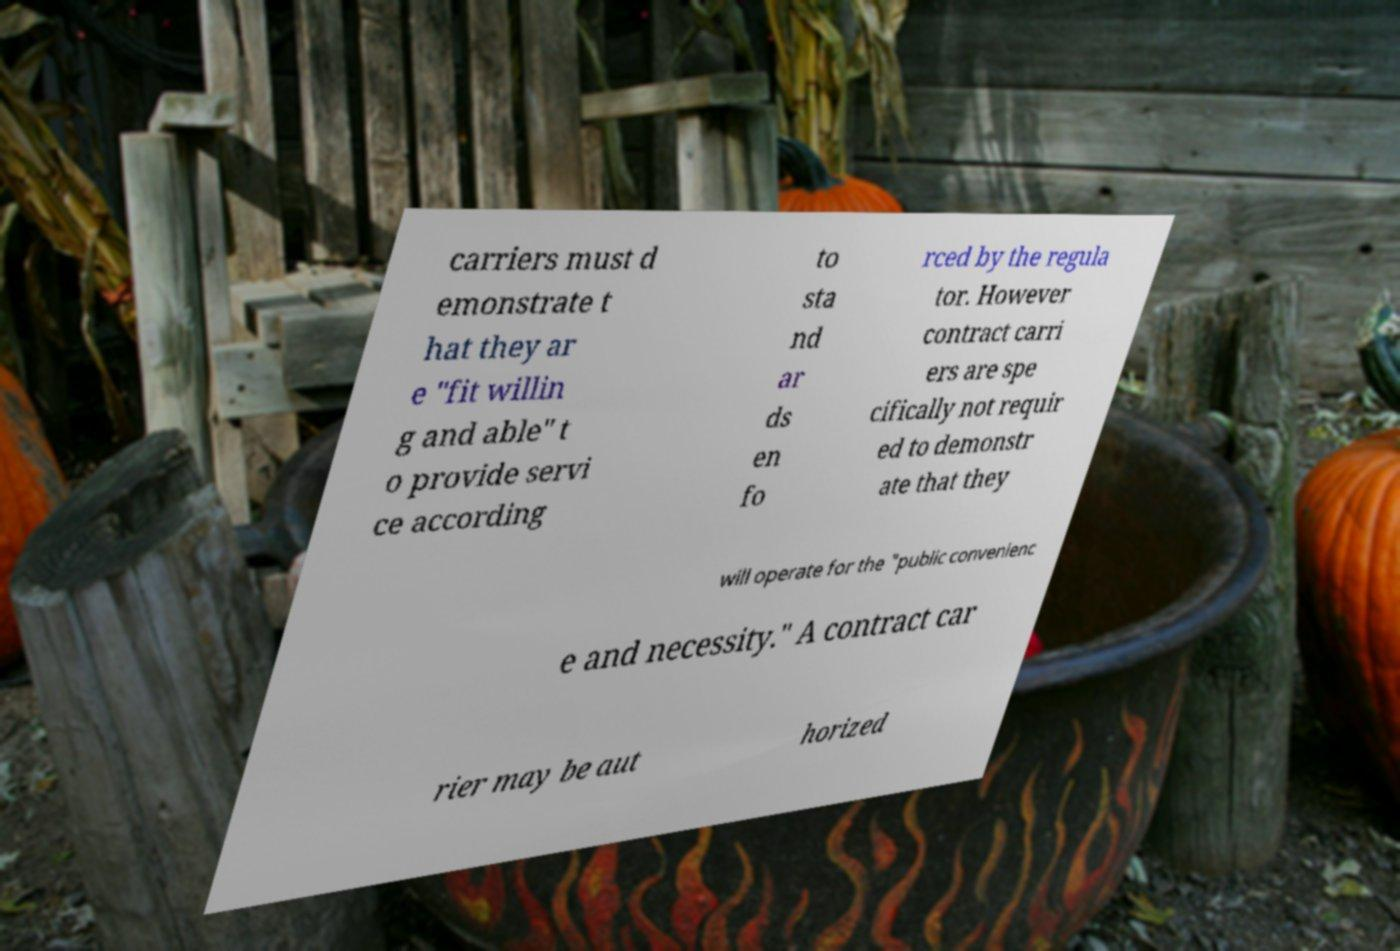Please read and relay the text visible in this image. What does it say? carriers must d emonstrate t hat they ar e "fit willin g and able" t o provide servi ce according to sta nd ar ds en fo rced by the regula tor. However contract carri ers are spe cifically not requir ed to demonstr ate that they will operate for the "public convenienc e and necessity." A contract car rier may be aut horized 